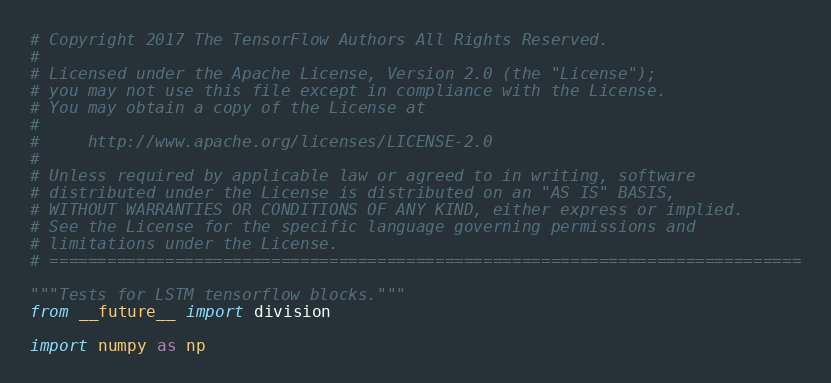<code> <loc_0><loc_0><loc_500><loc_500><_Python_># Copyright 2017 The TensorFlow Authors All Rights Reserved.
#
# Licensed under the Apache License, Version 2.0 (the "License");
# you may not use this file except in compliance with the License.
# You may obtain a copy of the License at
#
#     http://www.apache.org/licenses/LICENSE-2.0
#
# Unless required by applicable law or agreed to in writing, software
# distributed under the License is distributed on an "AS IS" BASIS,
# WITHOUT WARRANTIES OR CONDITIONS OF ANY KIND, either express or implied.
# See the License for the specific language governing permissions and
# limitations under the License.
# ==============================================================================

"""Tests for LSTM tensorflow blocks."""
from __future__ import division

import numpy as np</code> 